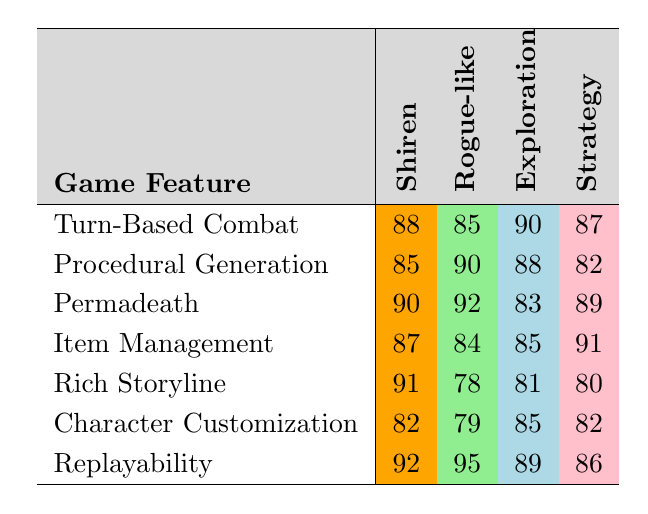What is the rating for "Turn-Based Combat" in Shiren? The table shows that the rating for "Turn-Based Combat" under the Shiren category is 88.
Answer: 88 Which game feature has the highest rating in the Rogue-like category? By comparing the ratings in the Rogue-like column, "Replayability" has the highest rating at 95.
Answer: 95 Is the rating for "Item Management" higher in Shiren than in Exploration? The rating for "Item Management" in Shiren is 87, and the rating in Exploration is 85. Since 87 > 85, the statement is true.
Answer: Yes What is the difference in ratings for "Rich Storyline" between Shiren and Rogue-like? The rating for "Rich Storyline" in Shiren is 91 and in Rogue-like is 78. The difference is 91 - 78 = 13.
Answer: 13 What is the average rating for procedural generation across all categories? The ratings for procedural generation are 85, 90, 88, and 82. Summing them gives 85 + 90 + 88 + 82 = 345, and dividing by the number of categories (4) gives 345/4 = 86.25.
Answer: 86.25 Which feature has the lowest rating in the strategy category? The ratings in the strategy column are 87, 82, 89, 91, 80, 82, and 86. The lowest rating among these is 80 for "Rich Storyline."
Answer: 80 Does "Permadeath" have a higher rating in Shiren compared to "Procedural Generation"? The rating for "Permadeath" in Shiren is 90, and for "Procedural Generation," it is 85. Since 90 > 85, the statement is true.
Answer: Yes What is the cumulative rating for "Replayability" across all categories? The ratings for "Replayability" are 92, 95, 89, and 86. Adding these together gives 92 + 95 + 89 + 86 = 362.
Answer: 362 For which feature does the Exploration rating equal or exceed 90? The table shows that "Turn-Based Combat" (90) and "Replayability" (89) are the only two features with ratings close to or above 90. Therefore, only "Turn-Based Combat" meets the criteria with 90.
Answer: Turn-Based Combat 